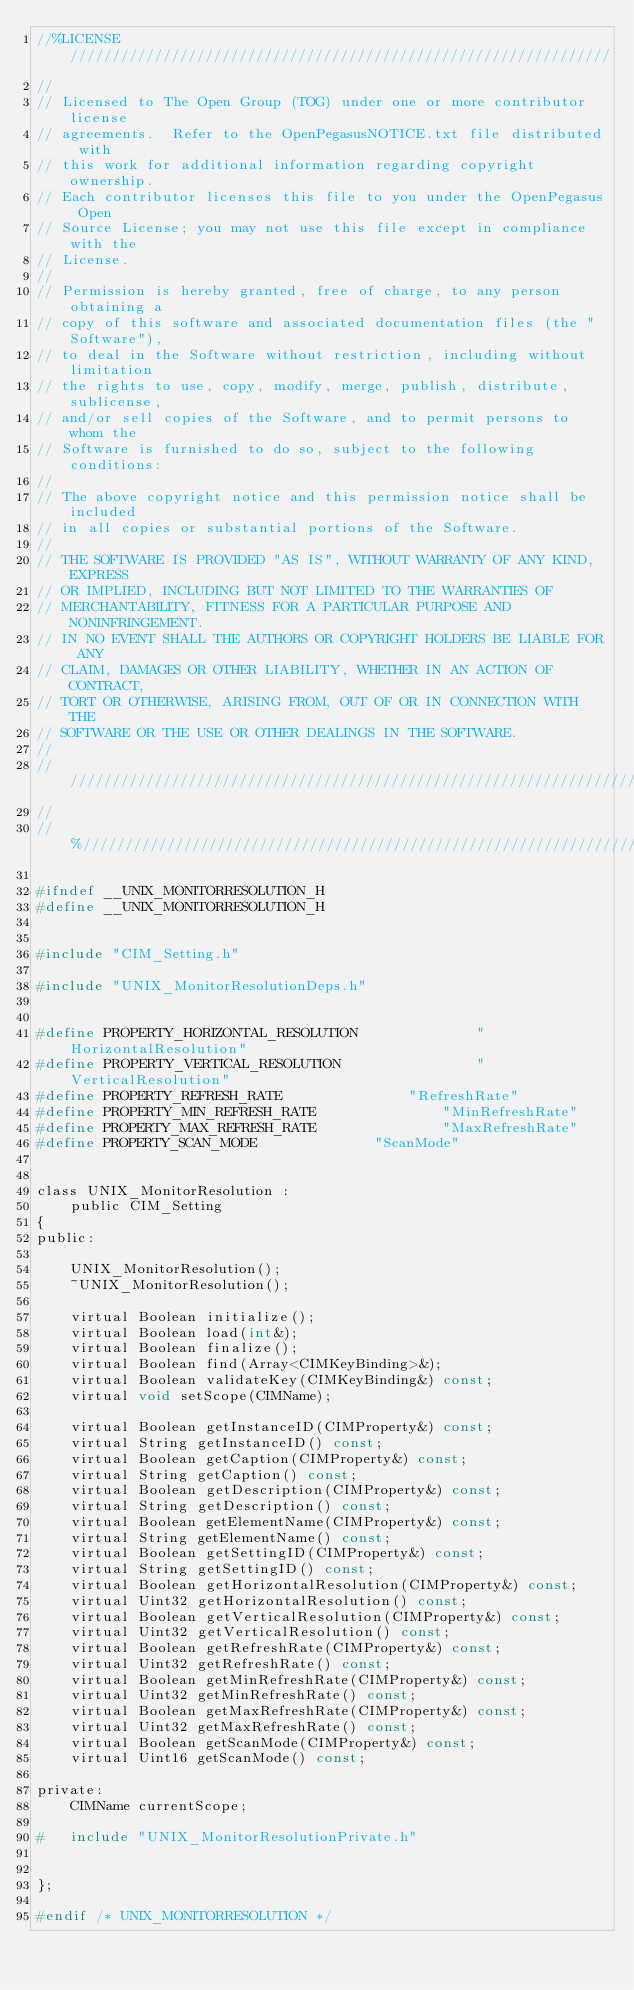<code> <loc_0><loc_0><loc_500><loc_500><_C_>//%LICENSE////////////////////////////////////////////////////////////////
//
// Licensed to The Open Group (TOG) under one or more contributor license
// agreements.  Refer to the OpenPegasusNOTICE.txt file distributed with
// this work for additional information regarding copyright ownership.
// Each contributor licenses this file to you under the OpenPegasus Open
// Source License; you may not use this file except in compliance with the
// License.
//
// Permission is hereby granted, free of charge, to any person obtaining a
// copy of this software and associated documentation files (the "Software"),
// to deal in the Software without restriction, including without limitation
// the rights to use, copy, modify, merge, publish, distribute, sublicense,
// and/or sell copies of the Software, and to permit persons to whom the
// Software is furnished to do so, subject to the following conditions:
//
// The above copyright notice and this permission notice shall be included
// in all copies or substantial portions of the Software.
//
// THE SOFTWARE IS PROVIDED "AS IS", WITHOUT WARRANTY OF ANY KIND, EXPRESS
// OR IMPLIED, INCLUDING BUT NOT LIMITED TO THE WARRANTIES OF
// MERCHANTABILITY, FITNESS FOR A PARTICULAR PURPOSE AND NONINFRINGEMENT.
// IN NO EVENT SHALL THE AUTHORS OR COPYRIGHT HOLDERS BE LIABLE FOR ANY
// CLAIM, DAMAGES OR OTHER LIABILITY, WHETHER IN AN ACTION OF CONTRACT,
// TORT OR OTHERWISE, ARISING FROM, OUT OF OR IN CONNECTION WITH THE
// SOFTWARE OR THE USE OR OTHER DEALINGS IN THE SOFTWARE.
//
//////////////////////////////////////////////////////////////////////////
//
//%/////////////////////////////////////////////////////////////////////////

#ifndef __UNIX_MONITORRESOLUTION_H
#define __UNIX_MONITORRESOLUTION_H


#include "CIM_Setting.h"

#include "UNIX_MonitorResolutionDeps.h"


#define PROPERTY_HORIZONTAL_RESOLUTION				"HorizontalResolution"
#define PROPERTY_VERTICAL_RESOLUTION				"VerticalResolution"
#define PROPERTY_REFRESH_RATE				"RefreshRate"
#define PROPERTY_MIN_REFRESH_RATE				"MinRefreshRate"
#define PROPERTY_MAX_REFRESH_RATE				"MaxRefreshRate"
#define PROPERTY_SCAN_MODE				"ScanMode"


class UNIX_MonitorResolution :
	public CIM_Setting
{
public:

	UNIX_MonitorResolution();
	~UNIX_MonitorResolution();

	virtual Boolean initialize();
	virtual Boolean load(int&);
	virtual Boolean finalize();
	virtual Boolean find(Array<CIMKeyBinding>&);
	virtual Boolean validateKey(CIMKeyBinding&) const;
	virtual void setScope(CIMName);

	virtual Boolean getInstanceID(CIMProperty&) const;
	virtual String getInstanceID() const;
	virtual Boolean getCaption(CIMProperty&) const;
	virtual String getCaption() const;
	virtual Boolean getDescription(CIMProperty&) const;
	virtual String getDescription() const;
	virtual Boolean getElementName(CIMProperty&) const;
	virtual String getElementName() const;
	virtual Boolean getSettingID(CIMProperty&) const;
	virtual String getSettingID() const;
	virtual Boolean getHorizontalResolution(CIMProperty&) const;
	virtual Uint32 getHorizontalResolution() const;
	virtual Boolean getVerticalResolution(CIMProperty&) const;
	virtual Uint32 getVerticalResolution() const;
	virtual Boolean getRefreshRate(CIMProperty&) const;
	virtual Uint32 getRefreshRate() const;
	virtual Boolean getMinRefreshRate(CIMProperty&) const;
	virtual Uint32 getMinRefreshRate() const;
	virtual Boolean getMaxRefreshRate(CIMProperty&) const;
	virtual Uint32 getMaxRefreshRate() const;
	virtual Boolean getScanMode(CIMProperty&) const;
	virtual Uint16 getScanMode() const;

private:
	CIMName currentScope;

#	include "UNIX_MonitorResolutionPrivate.h"


};

#endif /* UNIX_MONITORRESOLUTION */
</code> 